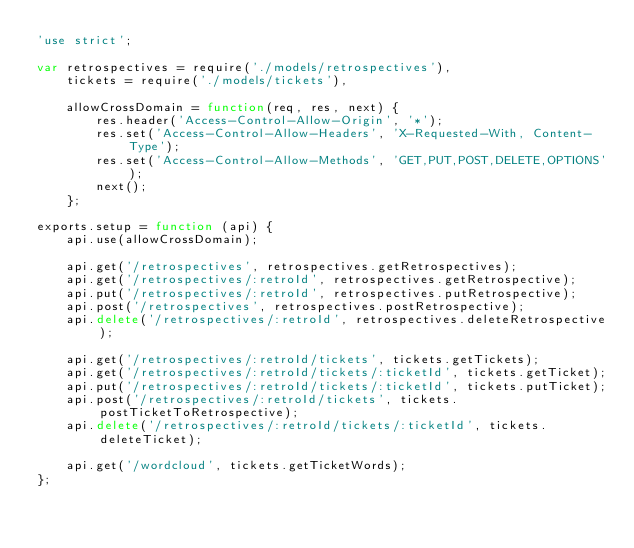<code> <loc_0><loc_0><loc_500><loc_500><_JavaScript_>'use strict';

var retrospectives = require('./models/retrospectives'),
    tickets = require('./models/tickets'),

    allowCrossDomain = function(req, res, next) {
        res.header('Access-Control-Allow-Origin', '*');
        res.set('Access-Control-Allow-Headers', 'X-Requested-With, Content-Type');
        res.set('Access-Control-Allow-Methods', 'GET,PUT,POST,DELETE,OPTIONS');
        next();
    };

exports.setup = function (api) {
    api.use(allowCrossDomain);

    api.get('/retrospectives', retrospectives.getRetrospectives);
    api.get('/retrospectives/:retroId', retrospectives.getRetrospective);
    api.put('/retrospectives/:retroId', retrospectives.putRetrospective);
    api.post('/retrospectives', retrospectives.postRetrospective);
    api.delete('/retrospectives/:retroId', retrospectives.deleteRetrospective);

    api.get('/retrospectives/:retroId/tickets', tickets.getTickets);
    api.get('/retrospectives/:retroId/tickets/:ticketId', tickets.getTicket);
    api.put('/retrospectives/:retroId/tickets/:ticketId', tickets.putTicket);
    api.post('/retrospectives/:retroId/tickets', tickets.postTicketToRetrospective);
    api.delete('/retrospectives/:retroId/tickets/:ticketId', tickets.deleteTicket);

    api.get('/wordcloud', tickets.getTicketWords);
};
</code> 